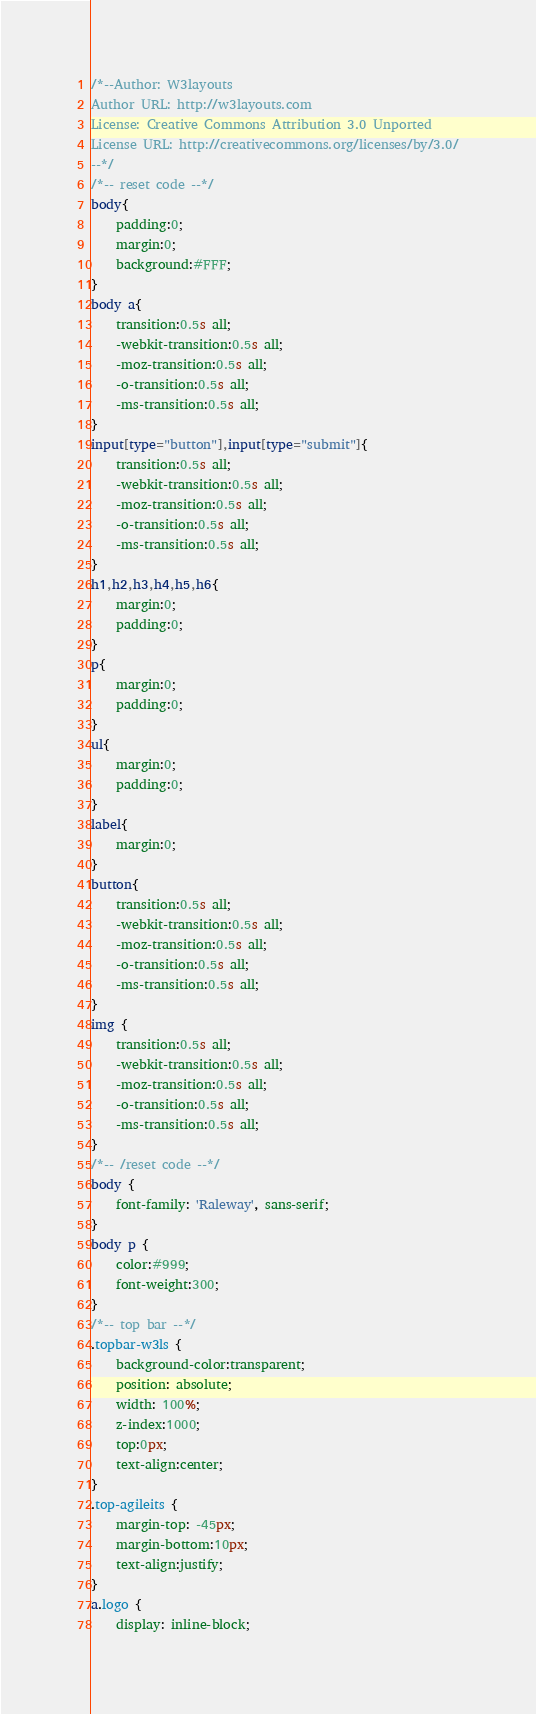Convert code to text. <code><loc_0><loc_0><loc_500><loc_500><_CSS_>/*--Author: W3layouts
Author URL: http://w3layouts.com
License: Creative Commons Attribution 3.0 Unported
License URL: http://creativecommons.org/licenses/by/3.0/
--*/
/*-- reset code --*/
body{
	padding:0;
	margin:0;
	background:#FFF;
}
body a{
    transition:0.5s all;
	-webkit-transition:0.5s all;
	-moz-transition:0.5s all;
	-o-transition:0.5s all;
	-ms-transition:0.5s all;
}
input[type="button"],input[type="submit"]{
	transition:0.5s all;
	-webkit-transition:0.5s all;
	-moz-transition:0.5s all;
	-o-transition:0.5s all;
	-ms-transition:0.5s all;
}
h1,h2,h3,h4,h5,h6{
	margin:0;	
	padding:0;
}	
p{
	margin:0;
	padding:0;
}
ul{
	margin:0;
	padding:0;
}
label{
	margin:0;
}
button{
	transition:0.5s all;
	-webkit-transition:0.5s all;
	-moz-transition:0.5s all;
	-o-transition:0.5s all;
	-ms-transition:0.5s all;
}
img {
	transition:0.5s all;
	-webkit-transition:0.5s all;
	-moz-transition:0.5s all;
	-o-transition:0.5s all;
	-ms-transition:0.5s all;
}
/*-- /reset code --*/
body {
	font-family: 'Raleway', sans-serif;
}
body p {
	color:#999;
	font-weight:300;
}
/*-- top bar --*/
.topbar-w3ls {
	background-color:transparent;
	position: absolute;
    width: 100%;
    z-index:1000;
    top:0px;
	text-align:center;
}
.top-agileits {
    margin-top: -45px;
	margin-bottom:10px;
	text-align:justify;
}
a.logo {
    display: inline-block;</code> 